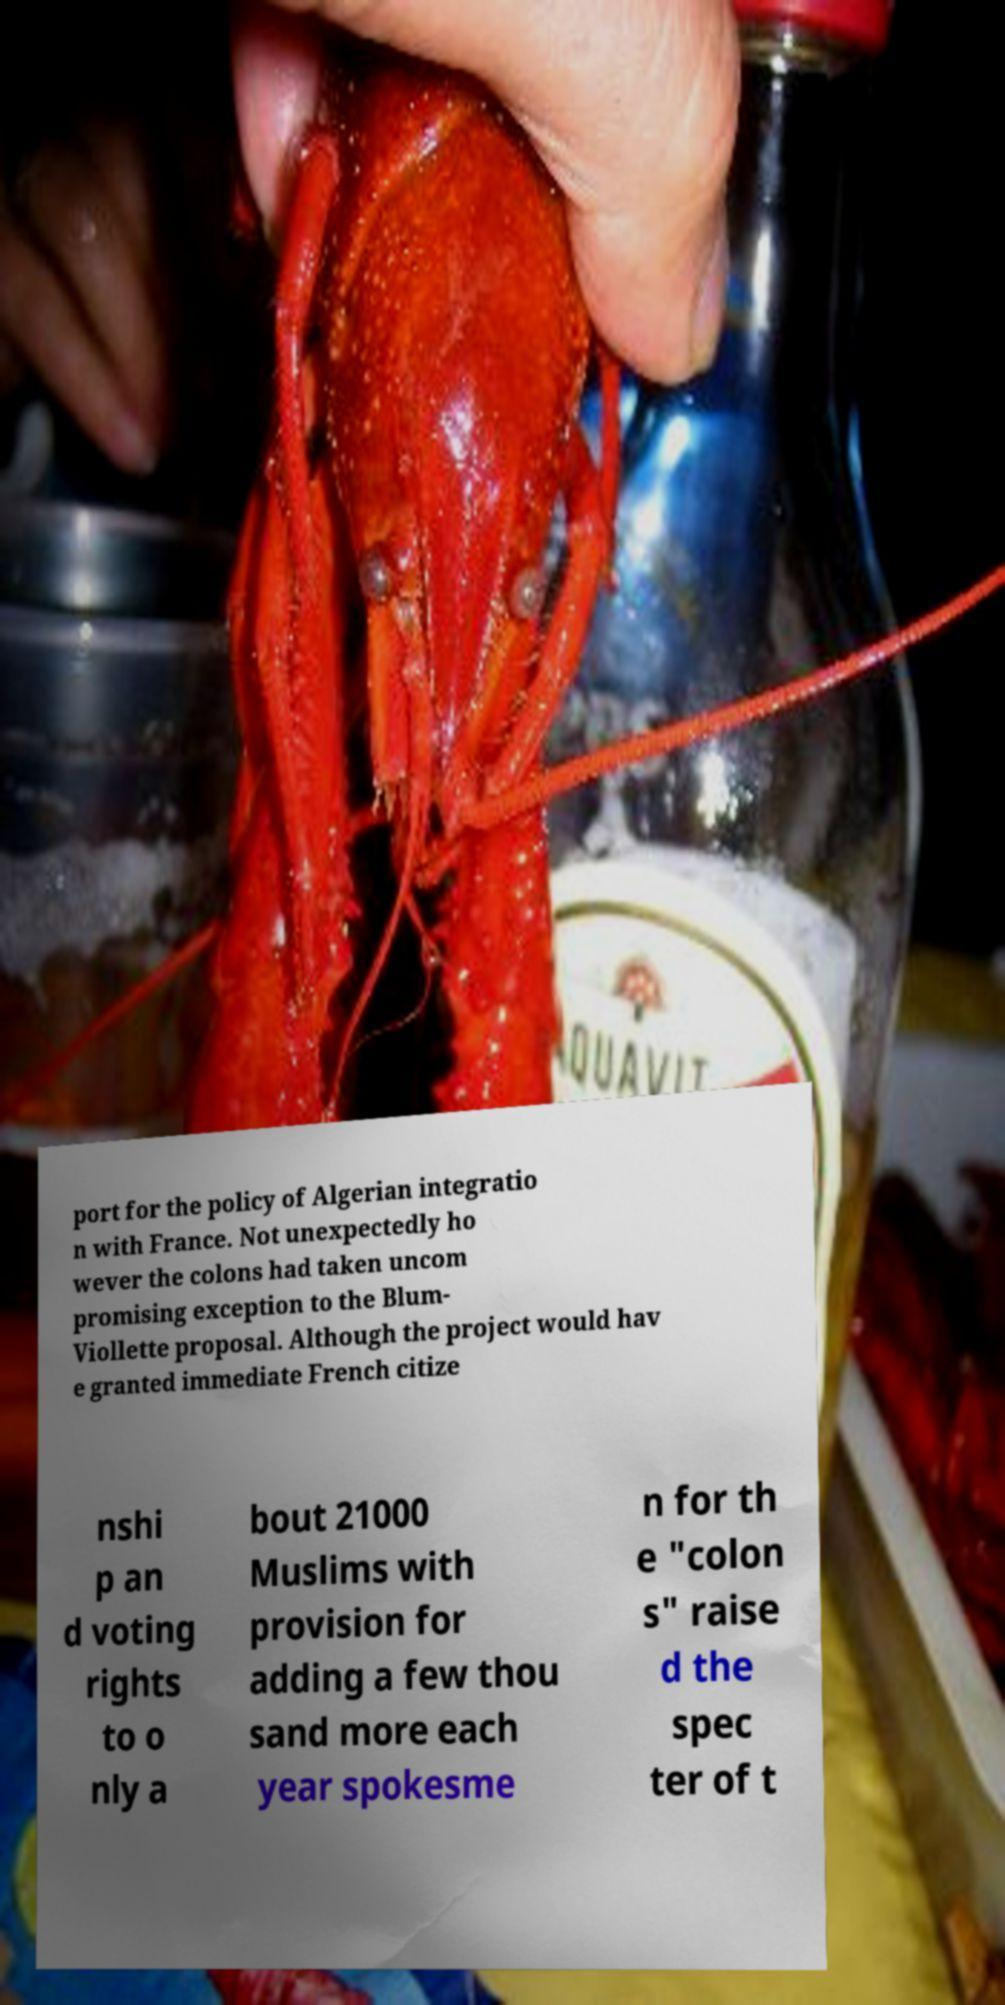Could you extract and type out the text from this image? port for the policy of Algerian integratio n with France. Not unexpectedly ho wever the colons had taken uncom promising exception to the Blum- Viollette proposal. Although the project would hav e granted immediate French citize nshi p an d voting rights to o nly a bout 21000 Muslims with provision for adding a few thou sand more each year spokesme n for th e "colon s" raise d the spec ter of t 